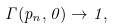<formula> <loc_0><loc_0><loc_500><loc_500>\Gamma ( p _ { n } , 0 ) \rightarrow 1 ,</formula> 